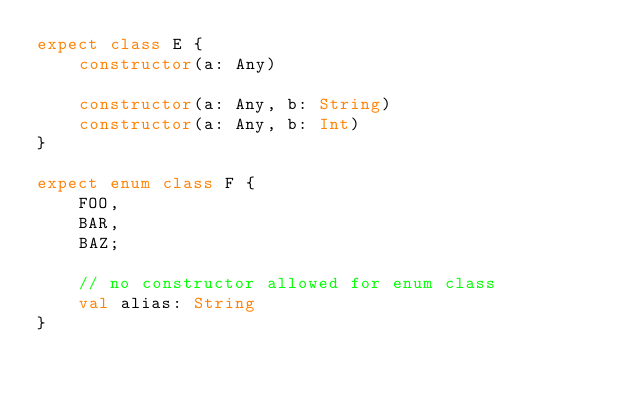Convert code to text. <code><loc_0><loc_0><loc_500><loc_500><_Kotlin_>expect class E {
    constructor(a: Any)

    constructor(a: Any, b: String)
    constructor(a: Any, b: Int)
}

expect enum class F {
    FOO,
    BAR,
    BAZ;

    // no constructor allowed for enum class
    val alias: String
}
</code> 